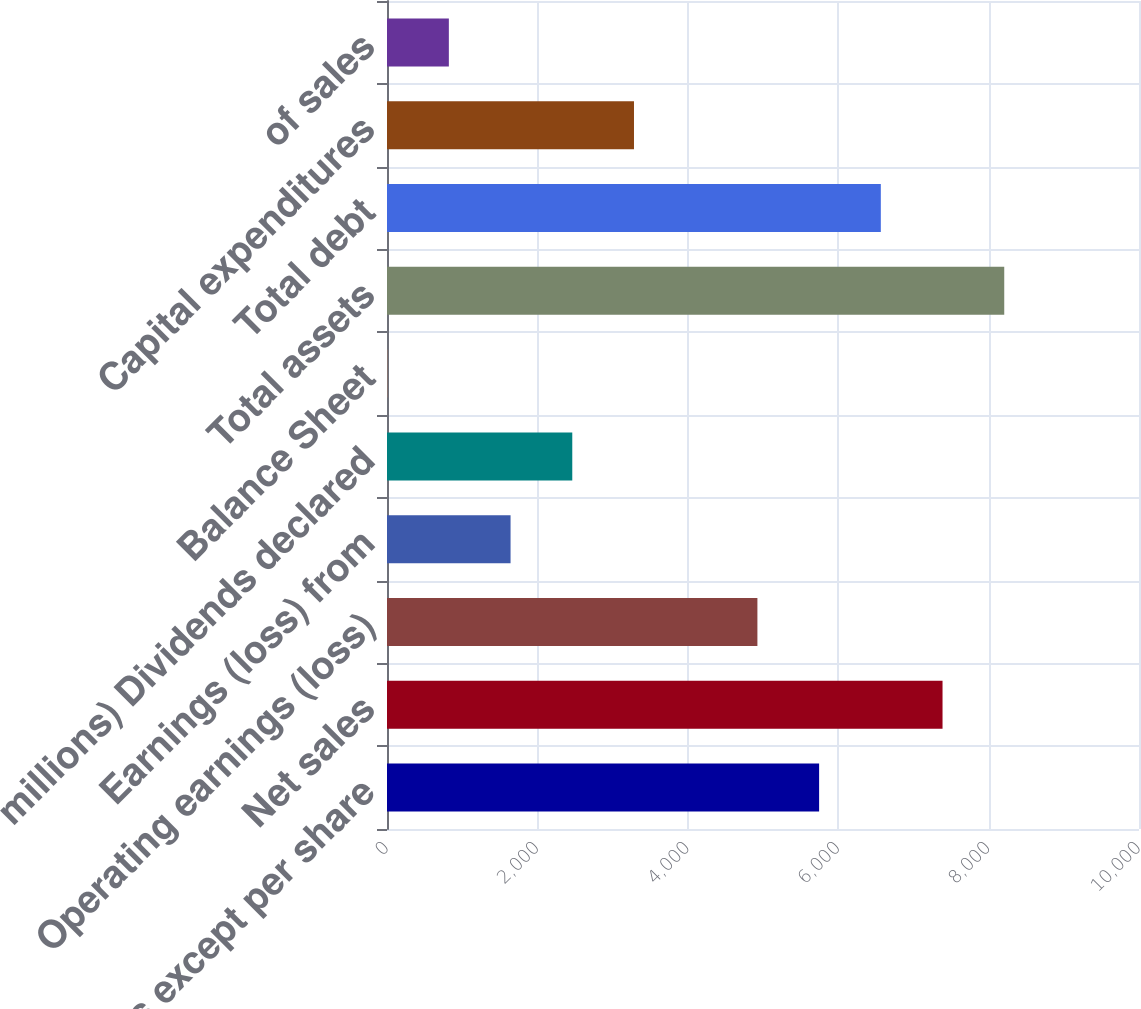<chart> <loc_0><loc_0><loc_500><loc_500><bar_chart><fcel>(In millions except per share<fcel>Net sales<fcel>Operating earnings (loss)<fcel>Earnings (loss) from<fcel>millions) Dividends declared<fcel>Balance Sheet<fcel>Total assets<fcel>Total debt<fcel>Capital expenditures<fcel>of sales<nl><fcel>5746.2<fcel>7387.42<fcel>4925.59<fcel>1643.15<fcel>2463.76<fcel>1.93<fcel>8208.03<fcel>6566.81<fcel>3284.37<fcel>822.54<nl></chart> 